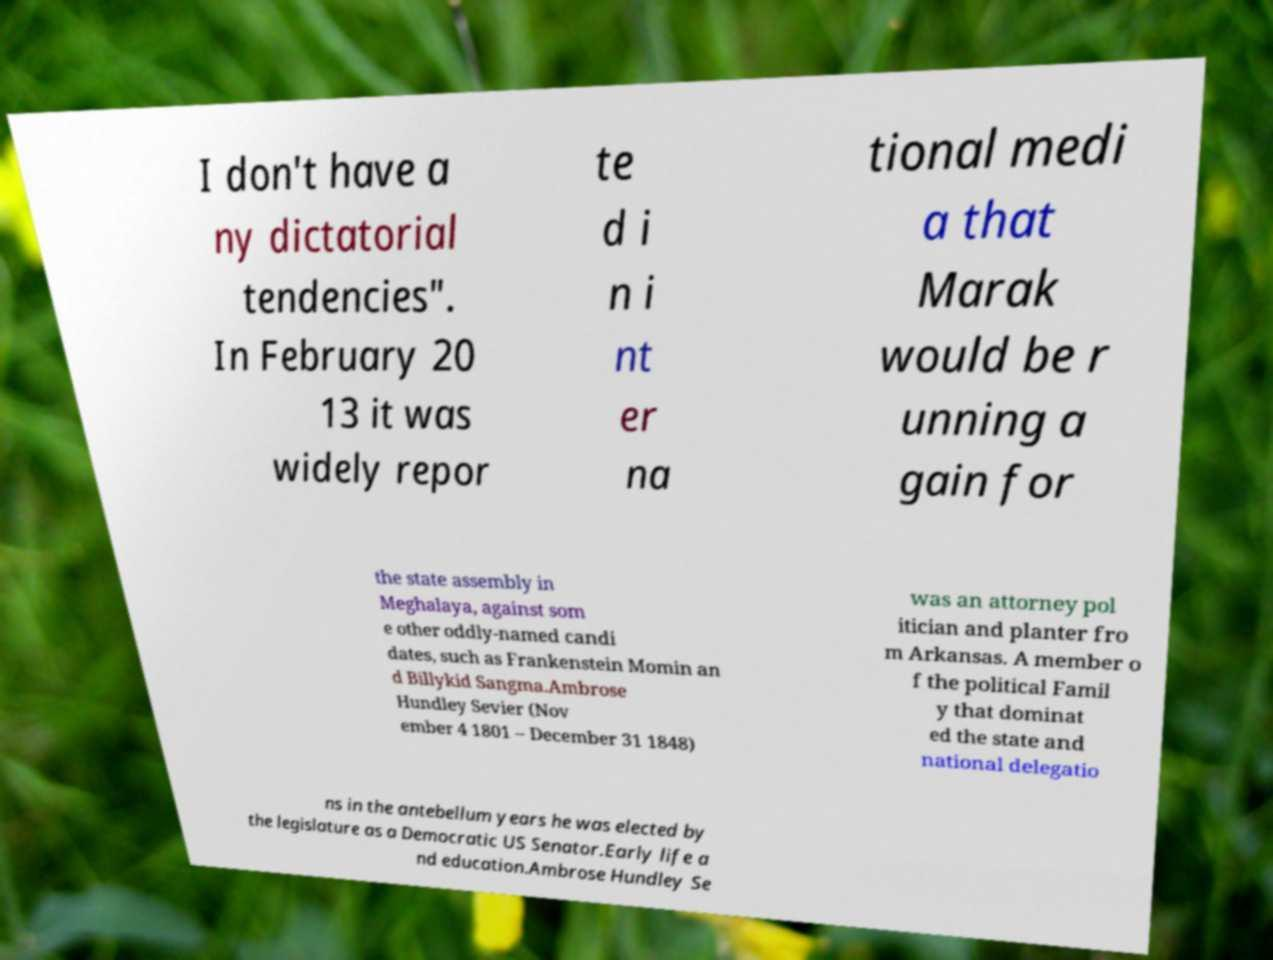Please read and relay the text visible in this image. What does it say? I don't have a ny dictatorial tendencies". In February 20 13 it was widely repor te d i n i nt er na tional medi a that Marak would be r unning a gain for the state assembly in Meghalaya, against som e other oddly-named candi dates, such as Frankenstein Momin an d Billykid Sangma.Ambrose Hundley Sevier (Nov ember 4 1801 – December 31 1848) was an attorney pol itician and planter fro m Arkansas. A member o f the political Famil y that dominat ed the state and national delegatio ns in the antebellum years he was elected by the legislature as a Democratic US Senator.Early life a nd education.Ambrose Hundley Se 